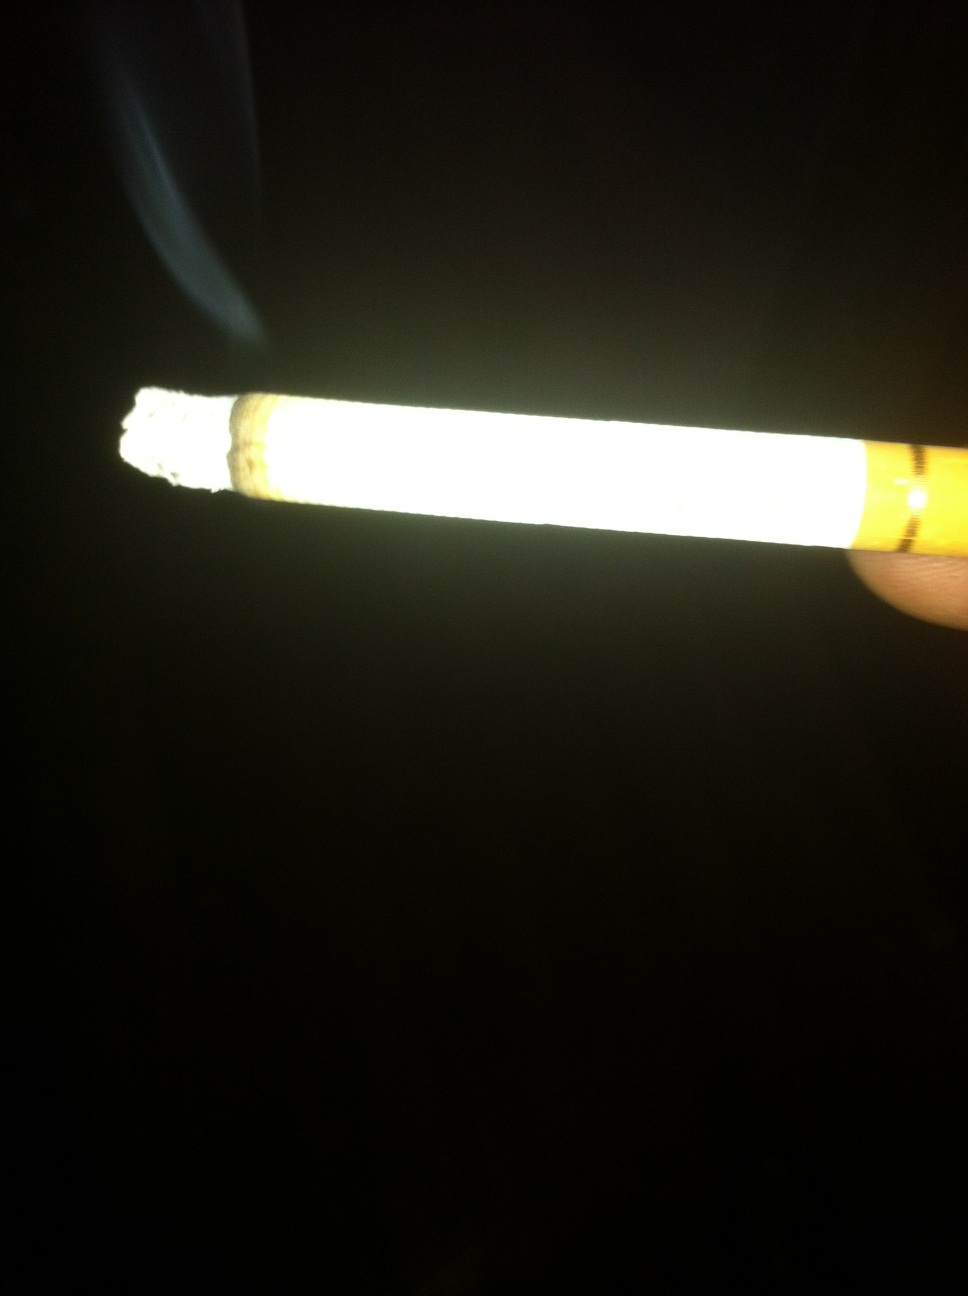what does this look like? from Vizwiz cigarette 